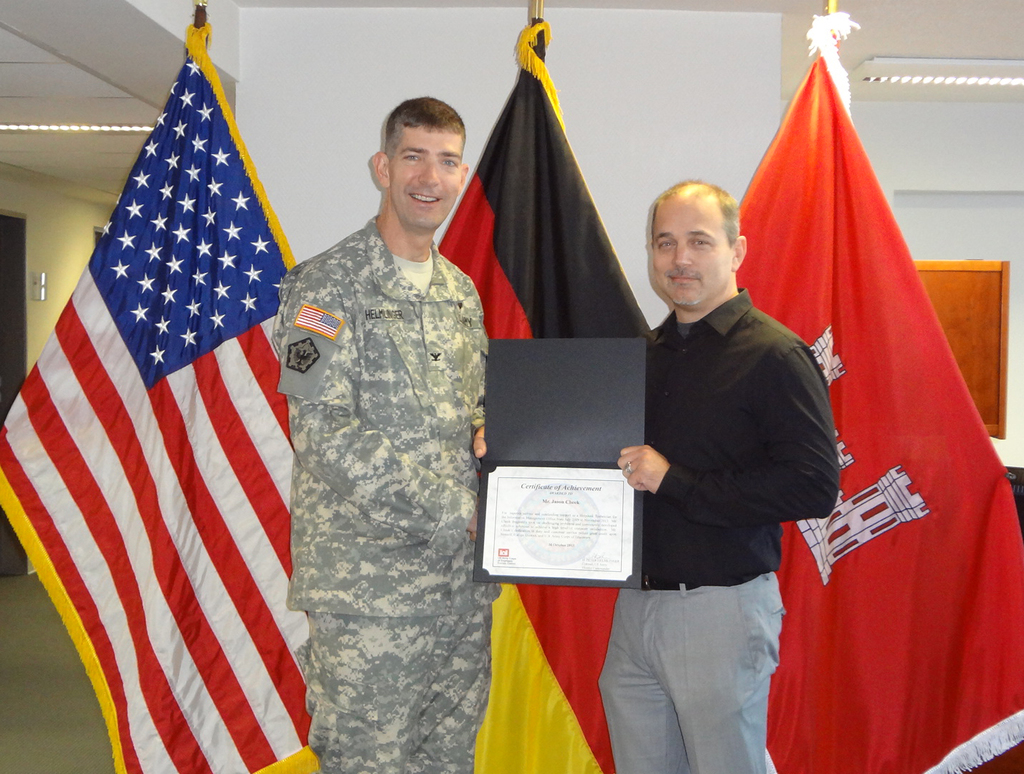What might be the occasion for this ceremony? The ceremony is likely a recognition event where the military officer is awarded a certificate of achievement, possibly for services or accomplishments that involve cooperation between American and German forces or organizations. What kind of achievements could be recognized in this type of ceremony? Such ceremonies typically recognize achievements like outstanding service, leadership in joint operations, significant contributions to collaborative projects, or efforts that strengthen international relations between the involved countries. 